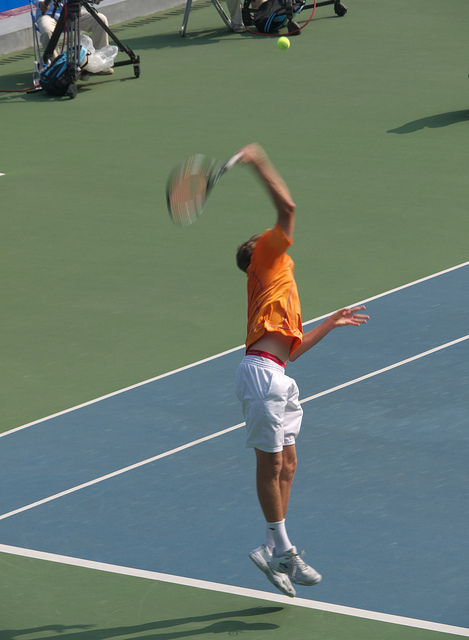<image>What color is he standing on? I don't know what color he is standing on. It could be either green or blue. What color is he standing on? I don't know what color he is standing on. It can be both green or blue. 